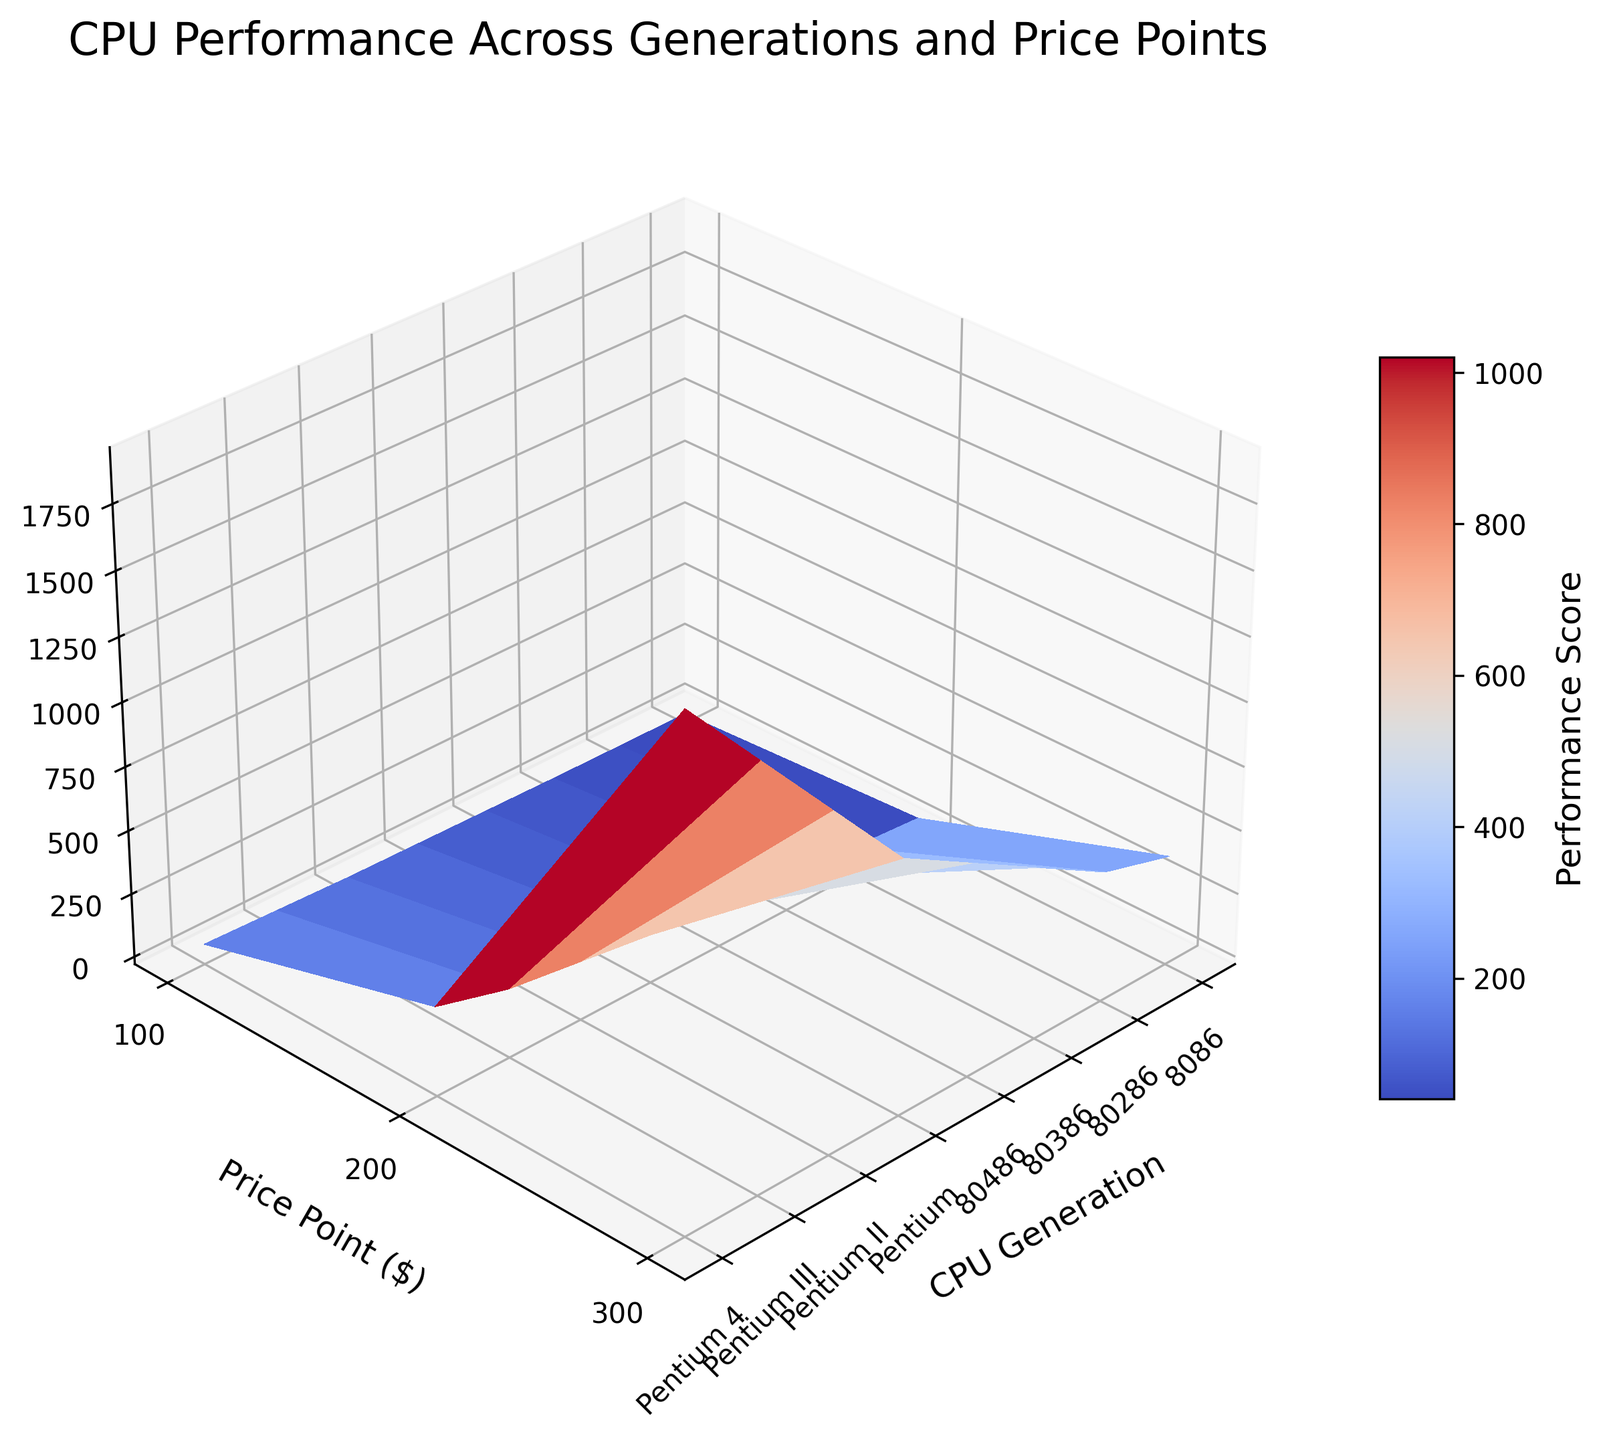What's the title of the figure? The title is usually found at the top of the chart, and here it reads 'CPU Performance Across Generations and Price Points'.
Answer: CPU Performance Across Generations and Price Points What do the axes represent? The x, y, and z-axes are labeled. The x-axis represents CPU Generation, the y-axis represents Price Point ($), and the z-axis represents Performance Score.
Answer: X: CPU Generation, Y: Price Point ($), Z: Performance Score What price points are considered in this plot? Look at the y-axis to see which labels are present. They include 100, 200, and 300.
Answer: 100, 200, 300 Which CPU generation has the highest performance score? The maximum point on the z-axis corresponds to the highest z value. According to the graph, Pentium 4 at a price point of $300 has the highest score.
Answer: Pentium 4 How does the performance score change from 8086 to Pentium 4 at a price point of 200? Locate points along the price point $200 line and compare their heights (z-axis values). It starts from around 12 for 8086 and goes up to 1600 for Pentium 4.
Answer: Increases significantly from 12 to 1600 How consistent is the improvement between each generation for each price point? Observe the smoothness and slopes of the surface between each CPU generation along lines for given price points. Consistently increasing slopes indicate steadier improvements.
Answer: Generally steady improvement At which generation and price point combination does the performance score first exceed 1000? Identify when the z-axis value first exceeds 1000 as you move through generations and price points. This occurs at Pentium III at the $300 price point.
Answer: Pentium III at $300 Is there a noticeable difference in performance improvement at lower price points compared to higher price points across generations? Compare the slope of performance scores for lower and higher price points across generations. Notice lower price points have slower increments than higher price points.
Answer: Yes, slower at lower price points How does the performance improvement rate change between 80386 and 80486 at the $200 price point? Compare the height difference on the z-axis between these two generations. The performance score increases from 50 to 100, doubling the rate.
Answer: Doubles from 50 to 100 How does the surface plot color change across different generations and price points? Observe the color gradient defined by the color map. As Performance Score increases, the color transitions from cool (blue) to warm (red).
Answer: Transitions from blue to red 